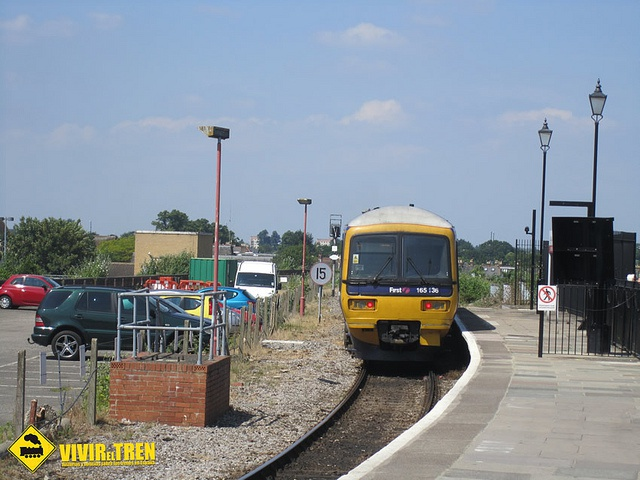Describe the objects in this image and their specific colors. I can see train in darkgray, black, gray, and darkblue tones, car in darkgray, black, darkblue, blue, and gray tones, car in darkgray, gray, brown, maroon, and black tones, and car in darkgray, teal, lightblue, blue, and gray tones in this image. 